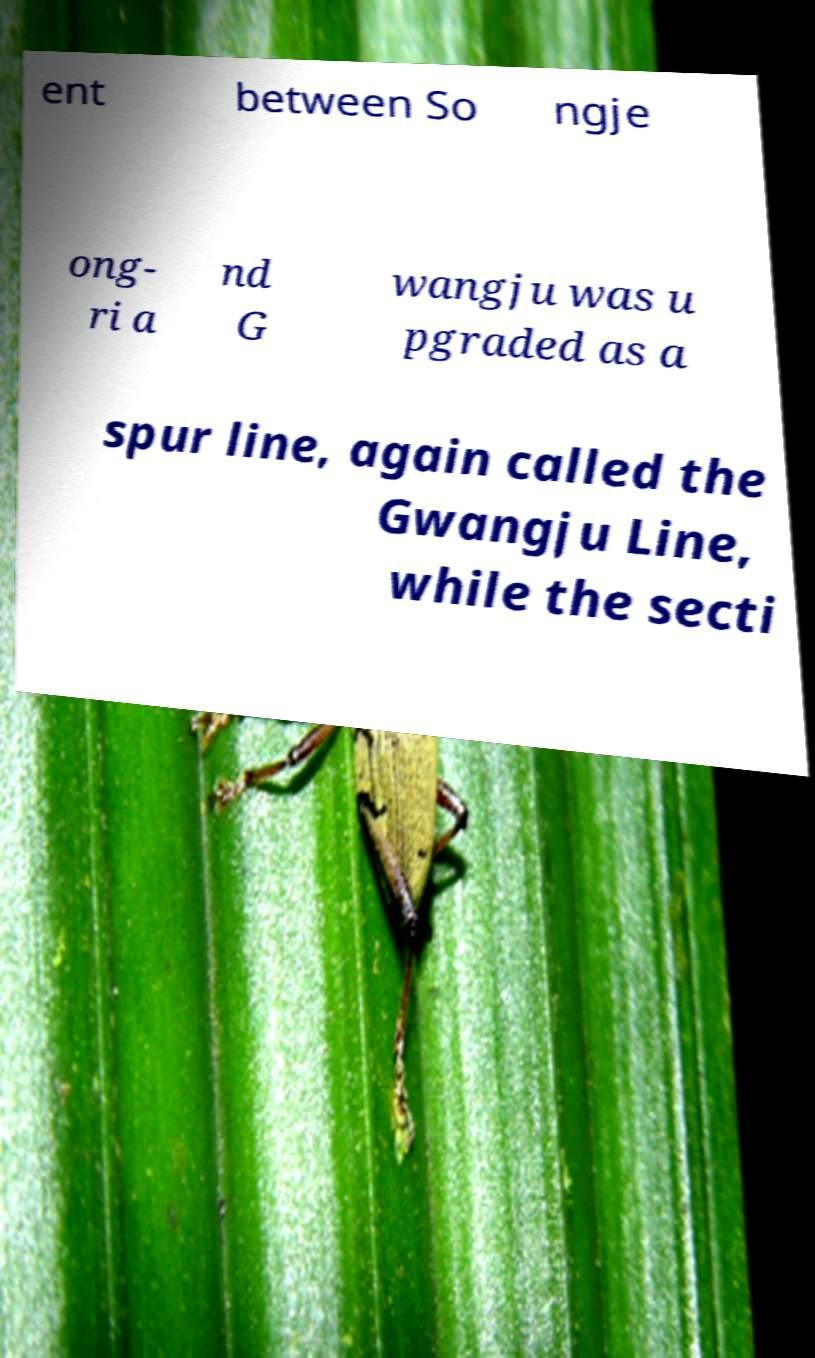There's text embedded in this image that I need extracted. Can you transcribe it verbatim? ent between So ngje ong- ri a nd G wangju was u pgraded as a spur line, again called the Gwangju Line, while the secti 